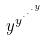Convert formula to latex. <formula><loc_0><loc_0><loc_500><loc_500>y ^ { y ^ { \cdot ^ { \cdot ^ { \cdot ^ { y } } } } }</formula> 